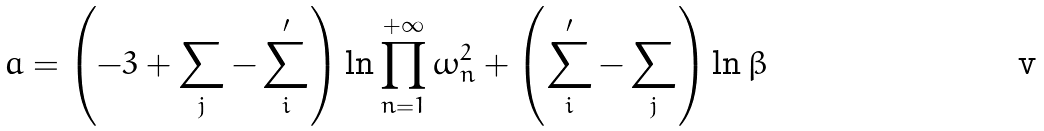Convert formula to latex. <formula><loc_0><loc_0><loc_500><loc_500>a = \left ( - 3 + \sum _ { j } - \sum _ { i } ^ { \prime } \right ) \ln \prod _ { n = 1 } ^ { + \infty } \omega _ { n } ^ { 2 } + \left ( \sum _ { i } ^ { \prime } - \sum _ { j } \right ) \ln \beta</formula> 